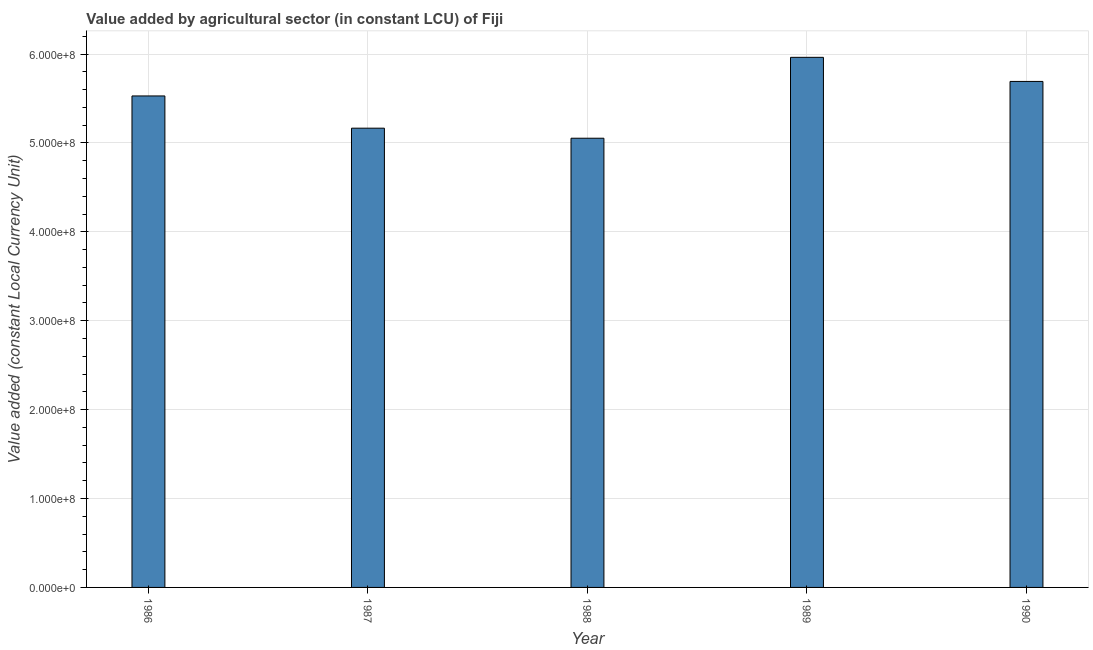Does the graph contain any zero values?
Your answer should be very brief. No. What is the title of the graph?
Your response must be concise. Value added by agricultural sector (in constant LCU) of Fiji. What is the label or title of the X-axis?
Offer a very short reply. Year. What is the label or title of the Y-axis?
Keep it short and to the point. Value added (constant Local Currency Unit). What is the value added by agriculture sector in 1988?
Provide a short and direct response. 5.05e+08. Across all years, what is the maximum value added by agriculture sector?
Offer a terse response. 5.96e+08. Across all years, what is the minimum value added by agriculture sector?
Offer a terse response. 5.05e+08. In which year was the value added by agriculture sector maximum?
Give a very brief answer. 1989. What is the sum of the value added by agriculture sector?
Offer a very short reply. 2.74e+09. What is the difference between the value added by agriculture sector in 1988 and 1989?
Your response must be concise. -9.10e+07. What is the average value added by agriculture sector per year?
Your response must be concise. 5.48e+08. What is the median value added by agriculture sector?
Ensure brevity in your answer.  5.53e+08. In how many years, is the value added by agriculture sector greater than 80000000 LCU?
Offer a very short reply. 5. Is the value added by agriculture sector in 1987 less than that in 1989?
Provide a succinct answer. Yes. Is the difference between the value added by agriculture sector in 1988 and 1990 greater than the difference between any two years?
Make the answer very short. No. What is the difference between the highest and the second highest value added by agriculture sector?
Your response must be concise. 2.71e+07. Is the sum of the value added by agriculture sector in 1986 and 1987 greater than the maximum value added by agriculture sector across all years?
Offer a terse response. Yes. What is the difference between the highest and the lowest value added by agriculture sector?
Your answer should be compact. 9.10e+07. How many years are there in the graph?
Offer a terse response. 5. What is the Value added (constant Local Currency Unit) of 1986?
Give a very brief answer. 5.53e+08. What is the Value added (constant Local Currency Unit) in 1987?
Offer a terse response. 5.17e+08. What is the Value added (constant Local Currency Unit) in 1988?
Your response must be concise. 5.05e+08. What is the Value added (constant Local Currency Unit) of 1989?
Give a very brief answer. 5.96e+08. What is the Value added (constant Local Currency Unit) of 1990?
Provide a short and direct response. 5.69e+08. What is the difference between the Value added (constant Local Currency Unit) in 1986 and 1987?
Offer a terse response. 3.63e+07. What is the difference between the Value added (constant Local Currency Unit) in 1986 and 1988?
Give a very brief answer. 4.76e+07. What is the difference between the Value added (constant Local Currency Unit) in 1986 and 1989?
Provide a short and direct response. -4.34e+07. What is the difference between the Value added (constant Local Currency Unit) in 1986 and 1990?
Give a very brief answer. -1.63e+07. What is the difference between the Value added (constant Local Currency Unit) in 1987 and 1988?
Make the answer very short. 1.13e+07. What is the difference between the Value added (constant Local Currency Unit) in 1987 and 1989?
Keep it short and to the point. -7.97e+07. What is the difference between the Value added (constant Local Currency Unit) in 1987 and 1990?
Make the answer very short. -5.26e+07. What is the difference between the Value added (constant Local Currency Unit) in 1988 and 1989?
Give a very brief answer. -9.10e+07. What is the difference between the Value added (constant Local Currency Unit) in 1988 and 1990?
Offer a terse response. -6.39e+07. What is the difference between the Value added (constant Local Currency Unit) in 1989 and 1990?
Give a very brief answer. 2.71e+07. What is the ratio of the Value added (constant Local Currency Unit) in 1986 to that in 1987?
Ensure brevity in your answer.  1.07. What is the ratio of the Value added (constant Local Currency Unit) in 1986 to that in 1988?
Your answer should be very brief. 1.09. What is the ratio of the Value added (constant Local Currency Unit) in 1986 to that in 1989?
Your answer should be compact. 0.93. What is the ratio of the Value added (constant Local Currency Unit) in 1986 to that in 1990?
Make the answer very short. 0.97. What is the ratio of the Value added (constant Local Currency Unit) in 1987 to that in 1988?
Keep it short and to the point. 1.02. What is the ratio of the Value added (constant Local Currency Unit) in 1987 to that in 1989?
Offer a very short reply. 0.87. What is the ratio of the Value added (constant Local Currency Unit) in 1987 to that in 1990?
Keep it short and to the point. 0.91. What is the ratio of the Value added (constant Local Currency Unit) in 1988 to that in 1989?
Keep it short and to the point. 0.85. What is the ratio of the Value added (constant Local Currency Unit) in 1988 to that in 1990?
Provide a short and direct response. 0.89. What is the ratio of the Value added (constant Local Currency Unit) in 1989 to that in 1990?
Make the answer very short. 1.05. 